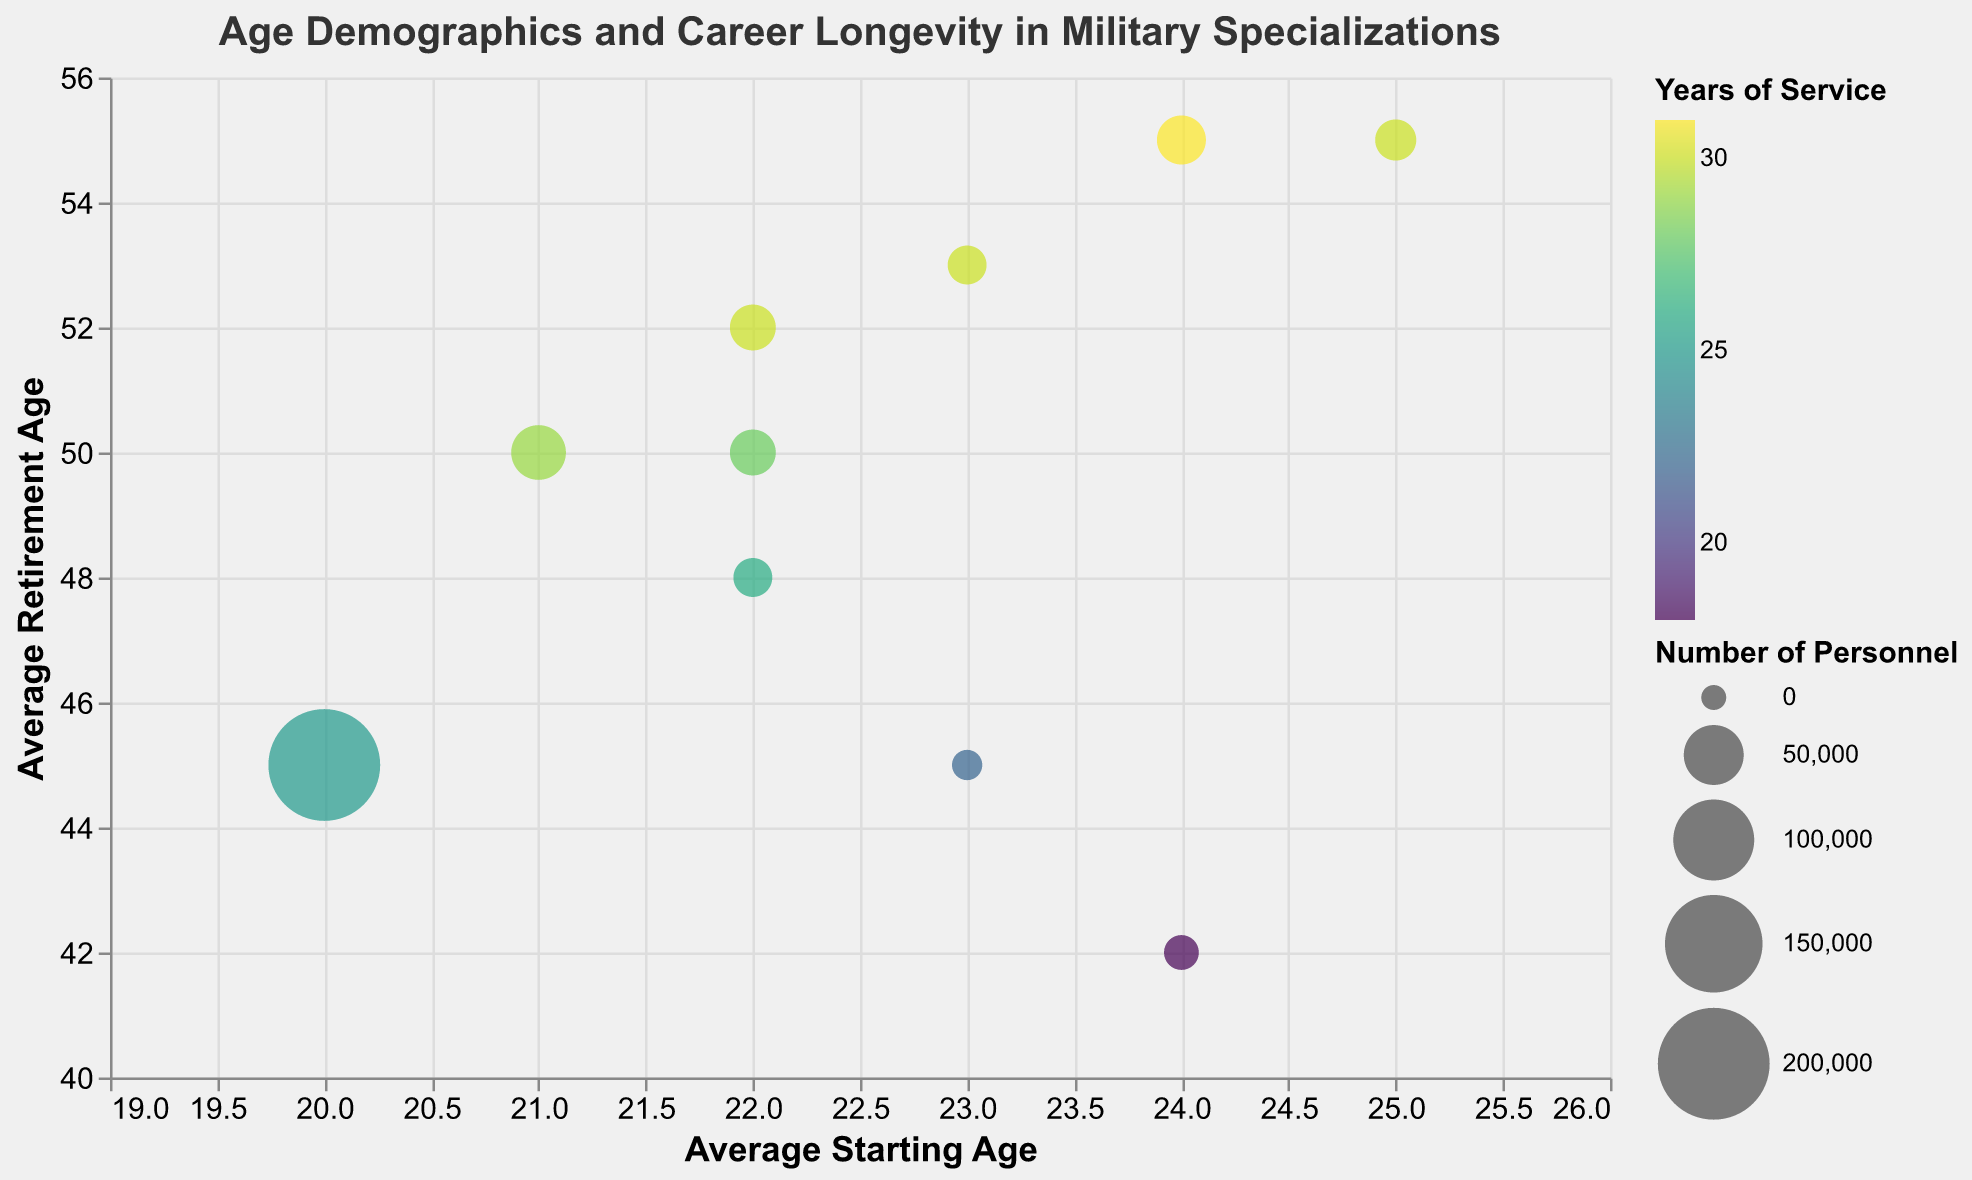What is the average starting age for Infantry personnel? The data shows the "Average Starting Age" for each military specialization. The value for Infantry is 20.
Answer: 20 Which military specialization has the highest average retirement age? The "Average Retirement Age" values in the data need to be compared. Military Intelligence and Medical Corps both have the highest average retirement age of 55.
Answer: Military Intelligence and Medical Corps How many years of service does the Engineering Corps have? The data specifies "Years of Service" for each field. The value for Engineering Corps is 30.
Answer: 30 Which specialization has the fewest number of personnel? The data provides the "Number of Personnel" for each specialization. Submarine Crew has the smallest number, which is 5,000.
Answer: Submarine Crew What is the difference between the average retirement ages of Cyber Warfare and Naval Officers? The "Average Retirement Age" for Cyber Warfare is 53 and for Naval Officers is 48. The difference is 53 - 48 = 5.
Answer: 5 Which military specialization has the largest circle in the bubble chart? The "Number of Personnel" determines the size of circles. Infantry, with 200,000 personnel, will have the largest circle.
Answer: Infantry What is the relationship between average starting age and average retirement age in general? By observing the overall trend in the chart, most specializations with higher average starting ages also have higher average retirement ages, except for Special Forces.
Answer: Higher starting ages generally correspond to higher retirement ages If we sum the years of service for Special Forces and Submarine Crew, what is the total? The years of service for Special Forces are 18 and for Submarine Crew are 22. Summing them gives 18 + 22 = 40.
Answer: 40 What is the average number of personnel across all military specializations? Add all the "Number of Personnel" values and divide by the number of categories: (200000 + 10000 + 25000 + 15000 + 5000 + 30000 + 18000 + 40000 + 15000 + 25000) / 10 = 44,800.
Answer: 44,800 Arrange the specializations in ascending order based on their average starting age. The average starting ages are as follows: Infantry (20), Logistics and Supply Chain (21), Aviation Pilots (22), Naval Officers (22), Engineering Corps (22), Submarine Crew (23), Cyber Warfare (23), Special Forces (24), Military Intelligence (24), Medical Corps (25). The order is: Infantry, Logistics and Supply Chain, Aviation Pilots/Naval Officers/Engineering Corps, Submarine Crew/Cyber Warfare, Special Forces/Military Intelligence, Medical Corps.
Answer: Infantry, Logistics and Supply Chain, Aviation Pilots, Naval Officers, Engineering Corps, Submarine Crew, Cyber Warfare, Special Forces, Military Intelligence, Medical Corps 